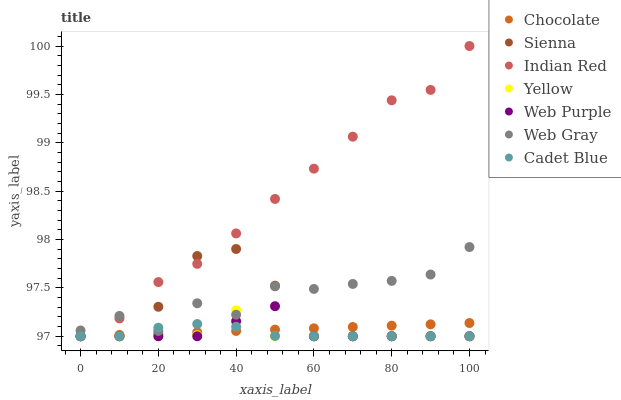Does Yellow have the minimum area under the curve?
Answer yes or no. Yes. Does Indian Red have the maximum area under the curve?
Answer yes or no. Yes. Does Chocolate have the minimum area under the curve?
Answer yes or no. No. Does Chocolate have the maximum area under the curve?
Answer yes or no. No. Is Chocolate the smoothest?
Answer yes or no. Yes. Is Web Gray the roughest?
Answer yes or no. Yes. Is Yellow the smoothest?
Answer yes or no. No. Is Yellow the roughest?
Answer yes or no. No. Does Yellow have the lowest value?
Answer yes or no. Yes. Does Indian Red have the highest value?
Answer yes or no. Yes. Does Yellow have the highest value?
Answer yes or no. No. Is Chocolate less than Web Gray?
Answer yes or no. Yes. Is Web Gray greater than Web Purple?
Answer yes or no. Yes. Does Sienna intersect Web Gray?
Answer yes or no. Yes. Is Sienna less than Web Gray?
Answer yes or no. No. Is Sienna greater than Web Gray?
Answer yes or no. No. Does Chocolate intersect Web Gray?
Answer yes or no. No. 